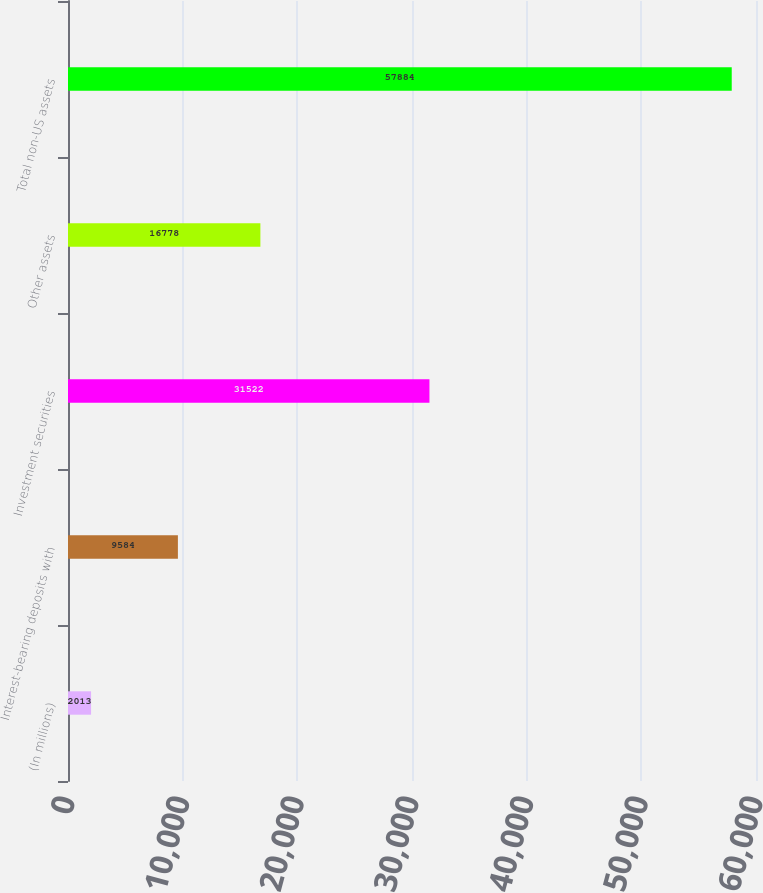Convert chart to OTSL. <chart><loc_0><loc_0><loc_500><loc_500><bar_chart><fcel>(In millions)<fcel>Interest-bearing deposits with<fcel>Investment securities<fcel>Other assets<fcel>Total non-US assets<nl><fcel>2013<fcel>9584<fcel>31522<fcel>16778<fcel>57884<nl></chart> 